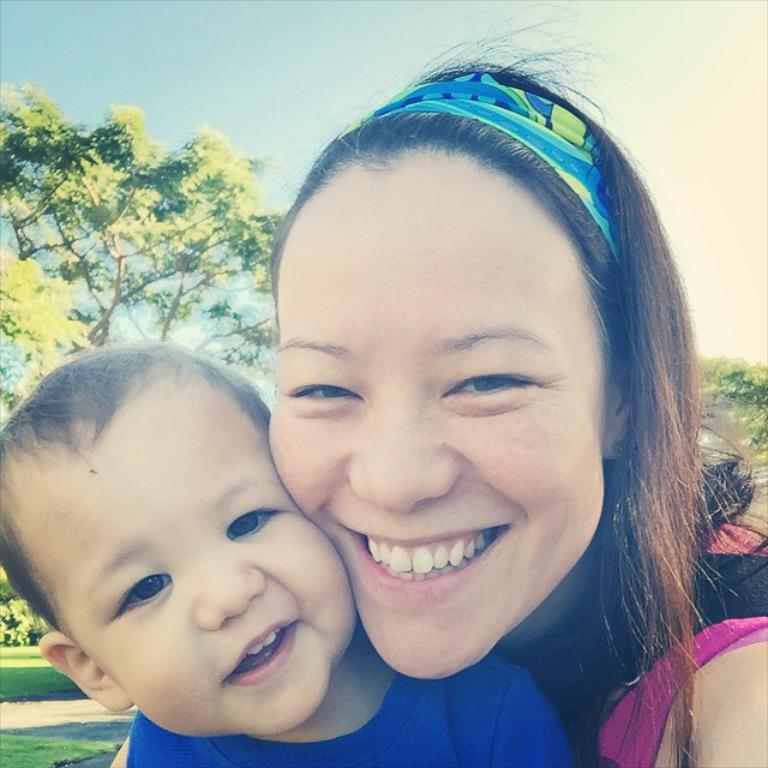Could you give a brief overview of what you see in this image? In this picture we can see a woman, boy, they are smiling and in the background we can see trees, grass, sky. 